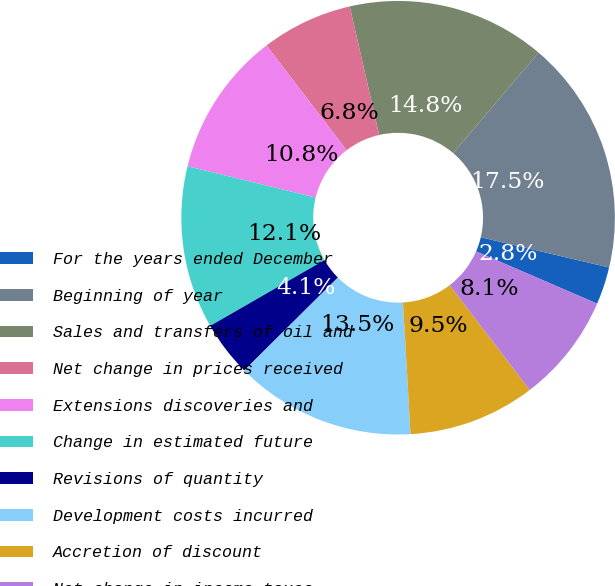Convert chart to OTSL. <chart><loc_0><loc_0><loc_500><loc_500><pie_chart><fcel>For the years ended December<fcel>Beginning of year<fcel>Sales and transfers of oil and<fcel>Net change in prices received<fcel>Extensions discoveries and<fcel>Change in estimated future<fcel>Revisions of quantity<fcel>Development costs incurred<fcel>Accretion of discount<fcel>Net change in income taxes<nl><fcel>2.8%<fcel>17.47%<fcel>14.8%<fcel>6.8%<fcel>10.8%<fcel>12.13%<fcel>4.13%<fcel>13.47%<fcel>9.47%<fcel>8.13%<nl></chart> 